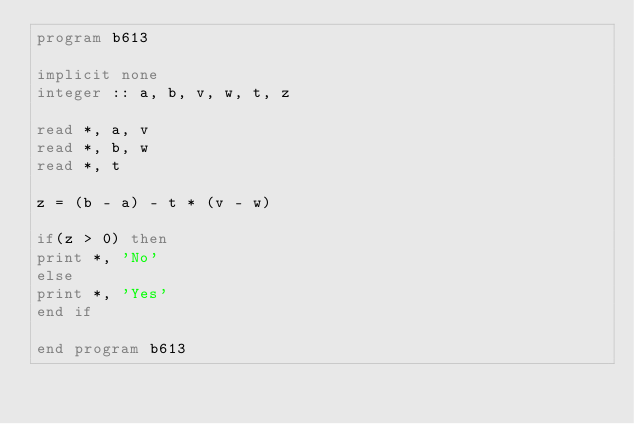Convert code to text. <code><loc_0><loc_0><loc_500><loc_500><_FORTRAN_>program b613

implicit none
integer :: a, b, v, w, t, z

read *, a, v
read *, b, w
read *, t

z = (b - a) - t * (v - w)

if(z > 0) then
print *, 'No'
else
print *, 'Yes'
end if

end program b613</code> 